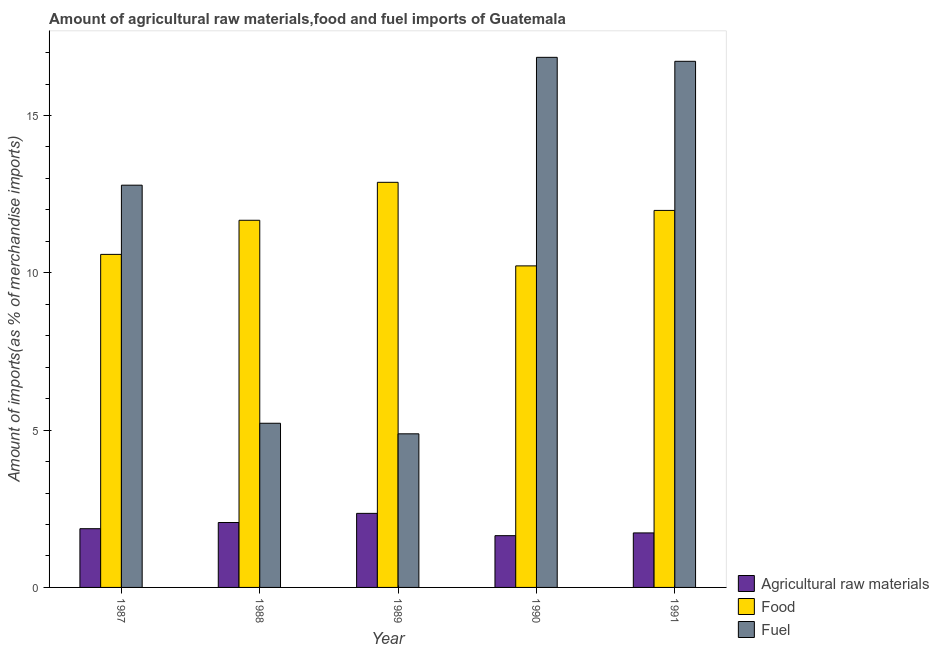Are the number of bars on each tick of the X-axis equal?
Provide a short and direct response. Yes. How many bars are there on the 4th tick from the right?
Your answer should be very brief. 3. What is the label of the 5th group of bars from the left?
Ensure brevity in your answer.  1991. What is the percentage of raw materials imports in 1990?
Provide a short and direct response. 1.65. Across all years, what is the maximum percentage of raw materials imports?
Your answer should be very brief. 2.35. Across all years, what is the minimum percentage of fuel imports?
Offer a terse response. 4.88. In which year was the percentage of raw materials imports maximum?
Offer a very short reply. 1989. What is the total percentage of raw materials imports in the graph?
Offer a terse response. 9.66. What is the difference between the percentage of fuel imports in 1987 and that in 1990?
Give a very brief answer. -4.06. What is the difference between the percentage of fuel imports in 1989 and the percentage of food imports in 1990?
Offer a terse response. -11.97. What is the average percentage of food imports per year?
Provide a succinct answer. 11.47. In the year 1991, what is the difference between the percentage of raw materials imports and percentage of food imports?
Keep it short and to the point. 0. What is the ratio of the percentage of food imports in 1988 to that in 1990?
Ensure brevity in your answer.  1.14. Is the percentage of food imports in 1988 less than that in 1990?
Keep it short and to the point. No. What is the difference between the highest and the second highest percentage of fuel imports?
Your answer should be compact. 0.13. What is the difference between the highest and the lowest percentage of fuel imports?
Make the answer very short. 11.97. What does the 1st bar from the left in 1987 represents?
Provide a short and direct response. Agricultural raw materials. What does the 2nd bar from the right in 1990 represents?
Your answer should be very brief. Food. How many bars are there?
Make the answer very short. 15. Are all the bars in the graph horizontal?
Offer a very short reply. No. How many years are there in the graph?
Your response must be concise. 5. Are the values on the major ticks of Y-axis written in scientific E-notation?
Give a very brief answer. No. Does the graph contain any zero values?
Make the answer very short. No. Does the graph contain grids?
Give a very brief answer. No. Where does the legend appear in the graph?
Provide a short and direct response. Bottom right. How are the legend labels stacked?
Offer a very short reply. Vertical. What is the title of the graph?
Provide a short and direct response. Amount of agricultural raw materials,food and fuel imports of Guatemala. Does "Unpaid family workers" appear as one of the legend labels in the graph?
Ensure brevity in your answer.  No. What is the label or title of the X-axis?
Ensure brevity in your answer.  Year. What is the label or title of the Y-axis?
Provide a succinct answer. Amount of imports(as % of merchandise imports). What is the Amount of imports(as % of merchandise imports) of Agricultural raw materials in 1987?
Give a very brief answer. 1.87. What is the Amount of imports(as % of merchandise imports) in Food in 1987?
Keep it short and to the point. 10.58. What is the Amount of imports(as % of merchandise imports) in Fuel in 1987?
Make the answer very short. 12.78. What is the Amount of imports(as % of merchandise imports) of Agricultural raw materials in 1988?
Ensure brevity in your answer.  2.06. What is the Amount of imports(as % of merchandise imports) of Food in 1988?
Give a very brief answer. 11.67. What is the Amount of imports(as % of merchandise imports) in Fuel in 1988?
Keep it short and to the point. 5.22. What is the Amount of imports(as % of merchandise imports) in Agricultural raw materials in 1989?
Keep it short and to the point. 2.35. What is the Amount of imports(as % of merchandise imports) of Food in 1989?
Ensure brevity in your answer.  12.88. What is the Amount of imports(as % of merchandise imports) of Fuel in 1989?
Offer a very short reply. 4.88. What is the Amount of imports(as % of merchandise imports) of Agricultural raw materials in 1990?
Your response must be concise. 1.65. What is the Amount of imports(as % of merchandise imports) of Food in 1990?
Your answer should be compact. 10.22. What is the Amount of imports(as % of merchandise imports) of Fuel in 1990?
Offer a terse response. 16.85. What is the Amount of imports(as % of merchandise imports) of Agricultural raw materials in 1991?
Give a very brief answer. 1.73. What is the Amount of imports(as % of merchandise imports) in Food in 1991?
Your answer should be compact. 11.98. What is the Amount of imports(as % of merchandise imports) of Fuel in 1991?
Provide a short and direct response. 16.72. Across all years, what is the maximum Amount of imports(as % of merchandise imports) in Agricultural raw materials?
Give a very brief answer. 2.35. Across all years, what is the maximum Amount of imports(as % of merchandise imports) of Food?
Provide a succinct answer. 12.88. Across all years, what is the maximum Amount of imports(as % of merchandise imports) in Fuel?
Your answer should be compact. 16.85. Across all years, what is the minimum Amount of imports(as % of merchandise imports) of Agricultural raw materials?
Provide a succinct answer. 1.65. Across all years, what is the minimum Amount of imports(as % of merchandise imports) in Food?
Offer a terse response. 10.22. Across all years, what is the minimum Amount of imports(as % of merchandise imports) of Fuel?
Provide a succinct answer. 4.88. What is the total Amount of imports(as % of merchandise imports) of Agricultural raw materials in the graph?
Your answer should be very brief. 9.66. What is the total Amount of imports(as % of merchandise imports) in Food in the graph?
Keep it short and to the point. 57.33. What is the total Amount of imports(as % of merchandise imports) in Fuel in the graph?
Provide a short and direct response. 56.45. What is the difference between the Amount of imports(as % of merchandise imports) of Agricultural raw materials in 1987 and that in 1988?
Provide a short and direct response. -0.2. What is the difference between the Amount of imports(as % of merchandise imports) in Food in 1987 and that in 1988?
Your answer should be very brief. -1.08. What is the difference between the Amount of imports(as % of merchandise imports) in Fuel in 1987 and that in 1988?
Your answer should be compact. 7.57. What is the difference between the Amount of imports(as % of merchandise imports) in Agricultural raw materials in 1987 and that in 1989?
Provide a succinct answer. -0.49. What is the difference between the Amount of imports(as % of merchandise imports) of Food in 1987 and that in 1989?
Offer a very short reply. -2.29. What is the difference between the Amount of imports(as % of merchandise imports) in Fuel in 1987 and that in 1989?
Your response must be concise. 7.9. What is the difference between the Amount of imports(as % of merchandise imports) of Agricultural raw materials in 1987 and that in 1990?
Offer a terse response. 0.22. What is the difference between the Amount of imports(as % of merchandise imports) in Food in 1987 and that in 1990?
Your response must be concise. 0.37. What is the difference between the Amount of imports(as % of merchandise imports) of Fuel in 1987 and that in 1990?
Keep it short and to the point. -4.06. What is the difference between the Amount of imports(as % of merchandise imports) in Agricultural raw materials in 1987 and that in 1991?
Give a very brief answer. 0.13. What is the difference between the Amount of imports(as % of merchandise imports) in Food in 1987 and that in 1991?
Offer a terse response. -1.4. What is the difference between the Amount of imports(as % of merchandise imports) of Fuel in 1987 and that in 1991?
Your response must be concise. -3.94. What is the difference between the Amount of imports(as % of merchandise imports) of Agricultural raw materials in 1988 and that in 1989?
Offer a terse response. -0.29. What is the difference between the Amount of imports(as % of merchandise imports) in Food in 1988 and that in 1989?
Provide a succinct answer. -1.21. What is the difference between the Amount of imports(as % of merchandise imports) in Fuel in 1988 and that in 1989?
Provide a succinct answer. 0.34. What is the difference between the Amount of imports(as % of merchandise imports) in Agricultural raw materials in 1988 and that in 1990?
Your answer should be very brief. 0.42. What is the difference between the Amount of imports(as % of merchandise imports) in Food in 1988 and that in 1990?
Ensure brevity in your answer.  1.45. What is the difference between the Amount of imports(as % of merchandise imports) in Fuel in 1988 and that in 1990?
Provide a succinct answer. -11.63. What is the difference between the Amount of imports(as % of merchandise imports) of Agricultural raw materials in 1988 and that in 1991?
Your answer should be compact. 0.33. What is the difference between the Amount of imports(as % of merchandise imports) in Food in 1988 and that in 1991?
Provide a succinct answer. -0.31. What is the difference between the Amount of imports(as % of merchandise imports) in Fuel in 1988 and that in 1991?
Provide a short and direct response. -11.5. What is the difference between the Amount of imports(as % of merchandise imports) in Agricultural raw materials in 1989 and that in 1990?
Your response must be concise. 0.71. What is the difference between the Amount of imports(as % of merchandise imports) of Food in 1989 and that in 1990?
Your response must be concise. 2.66. What is the difference between the Amount of imports(as % of merchandise imports) of Fuel in 1989 and that in 1990?
Your answer should be compact. -11.97. What is the difference between the Amount of imports(as % of merchandise imports) in Agricultural raw materials in 1989 and that in 1991?
Offer a very short reply. 0.62. What is the difference between the Amount of imports(as % of merchandise imports) of Food in 1989 and that in 1991?
Offer a terse response. 0.89. What is the difference between the Amount of imports(as % of merchandise imports) in Fuel in 1989 and that in 1991?
Provide a succinct answer. -11.84. What is the difference between the Amount of imports(as % of merchandise imports) in Agricultural raw materials in 1990 and that in 1991?
Offer a very short reply. -0.09. What is the difference between the Amount of imports(as % of merchandise imports) in Food in 1990 and that in 1991?
Keep it short and to the point. -1.76. What is the difference between the Amount of imports(as % of merchandise imports) in Fuel in 1990 and that in 1991?
Provide a succinct answer. 0.13. What is the difference between the Amount of imports(as % of merchandise imports) of Agricultural raw materials in 1987 and the Amount of imports(as % of merchandise imports) of Food in 1988?
Offer a very short reply. -9.8. What is the difference between the Amount of imports(as % of merchandise imports) in Agricultural raw materials in 1987 and the Amount of imports(as % of merchandise imports) in Fuel in 1988?
Keep it short and to the point. -3.35. What is the difference between the Amount of imports(as % of merchandise imports) of Food in 1987 and the Amount of imports(as % of merchandise imports) of Fuel in 1988?
Provide a short and direct response. 5.37. What is the difference between the Amount of imports(as % of merchandise imports) in Agricultural raw materials in 1987 and the Amount of imports(as % of merchandise imports) in Food in 1989?
Your answer should be compact. -11.01. What is the difference between the Amount of imports(as % of merchandise imports) of Agricultural raw materials in 1987 and the Amount of imports(as % of merchandise imports) of Fuel in 1989?
Your answer should be very brief. -3.02. What is the difference between the Amount of imports(as % of merchandise imports) in Food in 1987 and the Amount of imports(as % of merchandise imports) in Fuel in 1989?
Keep it short and to the point. 5.7. What is the difference between the Amount of imports(as % of merchandise imports) of Agricultural raw materials in 1987 and the Amount of imports(as % of merchandise imports) of Food in 1990?
Offer a very short reply. -8.35. What is the difference between the Amount of imports(as % of merchandise imports) in Agricultural raw materials in 1987 and the Amount of imports(as % of merchandise imports) in Fuel in 1990?
Give a very brief answer. -14.98. What is the difference between the Amount of imports(as % of merchandise imports) in Food in 1987 and the Amount of imports(as % of merchandise imports) in Fuel in 1990?
Ensure brevity in your answer.  -6.26. What is the difference between the Amount of imports(as % of merchandise imports) of Agricultural raw materials in 1987 and the Amount of imports(as % of merchandise imports) of Food in 1991?
Offer a very short reply. -10.12. What is the difference between the Amount of imports(as % of merchandise imports) in Agricultural raw materials in 1987 and the Amount of imports(as % of merchandise imports) in Fuel in 1991?
Provide a succinct answer. -14.86. What is the difference between the Amount of imports(as % of merchandise imports) of Food in 1987 and the Amount of imports(as % of merchandise imports) of Fuel in 1991?
Keep it short and to the point. -6.14. What is the difference between the Amount of imports(as % of merchandise imports) of Agricultural raw materials in 1988 and the Amount of imports(as % of merchandise imports) of Food in 1989?
Offer a terse response. -10.81. What is the difference between the Amount of imports(as % of merchandise imports) of Agricultural raw materials in 1988 and the Amount of imports(as % of merchandise imports) of Fuel in 1989?
Make the answer very short. -2.82. What is the difference between the Amount of imports(as % of merchandise imports) of Food in 1988 and the Amount of imports(as % of merchandise imports) of Fuel in 1989?
Give a very brief answer. 6.79. What is the difference between the Amount of imports(as % of merchandise imports) in Agricultural raw materials in 1988 and the Amount of imports(as % of merchandise imports) in Food in 1990?
Your response must be concise. -8.16. What is the difference between the Amount of imports(as % of merchandise imports) in Agricultural raw materials in 1988 and the Amount of imports(as % of merchandise imports) in Fuel in 1990?
Provide a short and direct response. -14.78. What is the difference between the Amount of imports(as % of merchandise imports) in Food in 1988 and the Amount of imports(as % of merchandise imports) in Fuel in 1990?
Your response must be concise. -5.18. What is the difference between the Amount of imports(as % of merchandise imports) of Agricultural raw materials in 1988 and the Amount of imports(as % of merchandise imports) of Food in 1991?
Your answer should be very brief. -9.92. What is the difference between the Amount of imports(as % of merchandise imports) of Agricultural raw materials in 1988 and the Amount of imports(as % of merchandise imports) of Fuel in 1991?
Keep it short and to the point. -14.66. What is the difference between the Amount of imports(as % of merchandise imports) of Food in 1988 and the Amount of imports(as % of merchandise imports) of Fuel in 1991?
Give a very brief answer. -5.05. What is the difference between the Amount of imports(as % of merchandise imports) of Agricultural raw materials in 1989 and the Amount of imports(as % of merchandise imports) of Food in 1990?
Your answer should be very brief. -7.87. What is the difference between the Amount of imports(as % of merchandise imports) in Agricultural raw materials in 1989 and the Amount of imports(as % of merchandise imports) in Fuel in 1990?
Your answer should be compact. -14.49. What is the difference between the Amount of imports(as % of merchandise imports) of Food in 1989 and the Amount of imports(as % of merchandise imports) of Fuel in 1990?
Your response must be concise. -3.97. What is the difference between the Amount of imports(as % of merchandise imports) of Agricultural raw materials in 1989 and the Amount of imports(as % of merchandise imports) of Food in 1991?
Provide a succinct answer. -9.63. What is the difference between the Amount of imports(as % of merchandise imports) of Agricultural raw materials in 1989 and the Amount of imports(as % of merchandise imports) of Fuel in 1991?
Your answer should be very brief. -14.37. What is the difference between the Amount of imports(as % of merchandise imports) of Food in 1989 and the Amount of imports(as % of merchandise imports) of Fuel in 1991?
Your response must be concise. -3.85. What is the difference between the Amount of imports(as % of merchandise imports) in Agricultural raw materials in 1990 and the Amount of imports(as % of merchandise imports) in Food in 1991?
Your answer should be very brief. -10.34. What is the difference between the Amount of imports(as % of merchandise imports) of Agricultural raw materials in 1990 and the Amount of imports(as % of merchandise imports) of Fuel in 1991?
Make the answer very short. -15.08. What is the difference between the Amount of imports(as % of merchandise imports) of Food in 1990 and the Amount of imports(as % of merchandise imports) of Fuel in 1991?
Keep it short and to the point. -6.5. What is the average Amount of imports(as % of merchandise imports) in Agricultural raw materials per year?
Make the answer very short. 1.93. What is the average Amount of imports(as % of merchandise imports) of Food per year?
Ensure brevity in your answer.  11.47. What is the average Amount of imports(as % of merchandise imports) in Fuel per year?
Your answer should be very brief. 11.29. In the year 1987, what is the difference between the Amount of imports(as % of merchandise imports) in Agricultural raw materials and Amount of imports(as % of merchandise imports) in Food?
Your response must be concise. -8.72. In the year 1987, what is the difference between the Amount of imports(as % of merchandise imports) in Agricultural raw materials and Amount of imports(as % of merchandise imports) in Fuel?
Provide a short and direct response. -10.92. In the year 1987, what is the difference between the Amount of imports(as % of merchandise imports) in Food and Amount of imports(as % of merchandise imports) in Fuel?
Provide a succinct answer. -2.2. In the year 1988, what is the difference between the Amount of imports(as % of merchandise imports) in Agricultural raw materials and Amount of imports(as % of merchandise imports) in Food?
Offer a very short reply. -9.61. In the year 1988, what is the difference between the Amount of imports(as % of merchandise imports) of Agricultural raw materials and Amount of imports(as % of merchandise imports) of Fuel?
Provide a succinct answer. -3.15. In the year 1988, what is the difference between the Amount of imports(as % of merchandise imports) in Food and Amount of imports(as % of merchandise imports) in Fuel?
Keep it short and to the point. 6.45. In the year 1989, what is the difference between the Amount of imports(as % of merchandise imports) in Agricultural raw materials and Amount of imports(as % of merchandise imports) in Food?
Keep it short and to the point. -10.52. In the year 1989, what is the difference between the Amount of imports(as % of merchandise imports) in Agricultural raw materials and Amount of imports(as % of merchandise imports) in Fuel?
Keep it short and to the point. -2.53. In the year 1989, what is the difference between the Amount of imports(as % of merchandise imports) in Food and Amount of imports(as % of merchandise imports) in Fuel?
Your response must be concise. 7.99. In the year 1990, what is the difference between the Amount of imports(as % of merchandise imports) in Agricultural raw materials and Amount of imports(as % of merchandise imports) in Food?
Provide a short and direct response. -8.57. In the year 1990, what is the difference between the Amount of imports(as % of merchandise imports) in Agricultural raw materials and Amount of imports(as % of merchandise imports) in Fuel?
Your response must be concise. -15.2. In the year 1990, what is the difference between the Amount of imports(as % of merchandise imports) of Food and Amount of imports(as % of merchandise imports) of Fuel?
Provide a succinct answer. -6.63. In the year 1991, what is the difference between the Amount of imports(as % of merchandise imports) of Agricultural raw materials and Amount of imports(as % of merchandise imports) of Food?
Offer a terse response. -10.25. In the year 1991, what is the difference between the Amount of imports(as % of merchandise imports) of Agricultural raw materials and Amount of imports(as % of merchandise imports) of Fuel?
Ensure brevity in your answer.  -14.99. In the year 1991, what is the difference between the Amount of imports(as % of merchandise imports) of Food and Amount of imports(as % of merchandise imports) of Fuel?
Your response must be concise. -4.74. What is the ratio of the Amount of imports(as % of merchandise imports) in Agricultural raw materials in 1987 to that in 1988?
Your answer should be compact. 0.9. What is the ratio of the Amount of imports(as % of merchandise imports) in Food in 1987 to that in 1988?
Offer a terse response. 0.91. What is the ratio of the Amount of imports(as % of merchandise imports) in Fuel in 1987 to that in 1988?
Ensure brevity in your answer.  2.45. What is the ratio of the Amount of imports(as % of merchandise imports) of Agricultural raw materials in 1987 to that in 1989?
Offer a very short reply. 0.79. What is the ratio of the Amount of imports(as % of merchandise imports) of Food in 1987 to that in 1989?
Keep it short and to the point. 0.82. What is the ratio of the Amount of imports(as % of merchandise imports) in Fuel in 1987 to that in 1989?
Your answer should be compact. 2.62. What is the ratio of the Amount of imports(as % of merchandise imports) in Agricultural raw materials in 1987 to that in 1990?
Keep it short and to the point. 1.13. What is the ratio of the Amount of imports(as % of merchandise imports) of Food in 1987 to that in 1990?
Provide a short and direct response. 1.04. What is the ratio of the Amount of imports(as % of merchandise imports) in Fuel in 1987 to that in 1990?
Your answer should be very brief. 0.76. What is the ratio of the Amount of imports(as % of merchandise imports) of Agricultural raw materials in 1987 to that in 1991?
Offer a terse response. 1.08. What is the ratio of the Amount of imports(as % of merchandise imports) of Food in 1987 to that in 1991?
Provide a succinct answer. 0.88. What is the ratio of the Amount of imports(as % of merchandise imports) in Fuel in 1987 to that in 1991?
Make the answer very short. 0.76. What is the ratio of the Amount of imports(as % of merchandise imports) of Agricultural raw materials in 1988 to that in 1989?
Give a very brief answer. 0.88. What is the ratio of the Amount of imports(as % of merchandise imports) in Food in 1988 to that in 1989?
Provide a succinct answer. 0.91. What is the ratio of the Amount of imports(as % of merchandise imports) in Fuel in 1988 to that in 1989?
Provide a succinct answer. 1.07. What is the ratio of the Amount of imports(as % of merchandise imports) in Agricultural raw materials in 1988 to that in 1990?
Make the answer very short. 1.25. What is the ratio of the Amount of imports(as % of merchandise imports) of Food in 1988 to that in 1990?
Offer a very short reply. 1.14. What is the ratio of the Amount of imports(as % of merchandise imports) in Fuel in 1988 to that in 1990?
Offer a very short reply. 0.31. What is the ratio of the Amount of imports(as % of merchandise imports) of Agricultural raw materials in 1988 to that in 1991?
Offer a terse response. 1.19. What is the ratio of the Amount of imports(as % of merchandise imports) of Food in 1988 to that in 1991?
Make the answer very short. 0.97. What is the ratio of the Amount of imports(as % of merchandise imports) in Fuel in 1988 to that in 1991?
Your response must be concise. 0.31. What is the ratio of the Amount of imports(as % of merchandise imports) in Agricultural raw materials in 1989 to that in 1990?
Offer a very short reply. 1.43. What is the ratio of the Amount of imports(as % of merchandise imports) in Food in 1989 to that in 1990?
Offer a terse response. 1.26. What is the ratio of the Amount of imports(as % of merchandise imports) in Fuel in 1989 to that in 1990?
Make the answer very short. 0.29. What is the ratio of the Amount of imports(as % of merchandise imports) of Agricultural raw materials in 1989 to that in 1991?
Ensure brevity in your answer.  1.36. What is the ratio of the Amount of imports(as % of merchandise imports) of Food in 1989 to that in 1991?
Give a very brief answer. 1.07. What is the ratio of the Amount of imports(as % of merchandise imports) in Fuel in 1989 to that in 1991?
Make the answer very short. 0.29. What is the ratio of the Amount of imports(as % of merchandise imports) of Agricultural raw materials in 1990 to that in 1991?
Offer a terse response. 0.95. What is the ratio of the Amount of imports(as % of merchandise imports) of Food in 1990 to that in 1991?
Provide a succinct answer. 0.85. What is the ratio of the Amount of imports(as % of merchandise imports) of Fuel in 1990 to that in 1991?
Your response must be concise. 1.01. What is the difference between the highest and the second highest Amount of imports(as % of merchandise imports) in Agricultural raw materials?
Your answer should be very brief. 0.29. What is the difference between the highest and the second highest Amount of imports(as % of merchandise imports) in Food?
Your response must be concise. 0.89. What is the difference between the highest and the second highest Amount of imports(as % of merchandise imports) of Fuel?
Keep it short and to the point. 0.13. What is the difference between the highest and the lowest Amount of imports(as % of merchandise imports) in Agricultural raw materials?
Offer a very short reply. 0.71. What is the difference between the highest and the lowest Amount of imports(as % of merchandise imports) in Food?
Keep it short and to the point. 2.66. What is the difference between the highest and the lowest Amount of imports(as % of merchandise imports) in Fuel?
Provide a short and direct response. 11.97. 